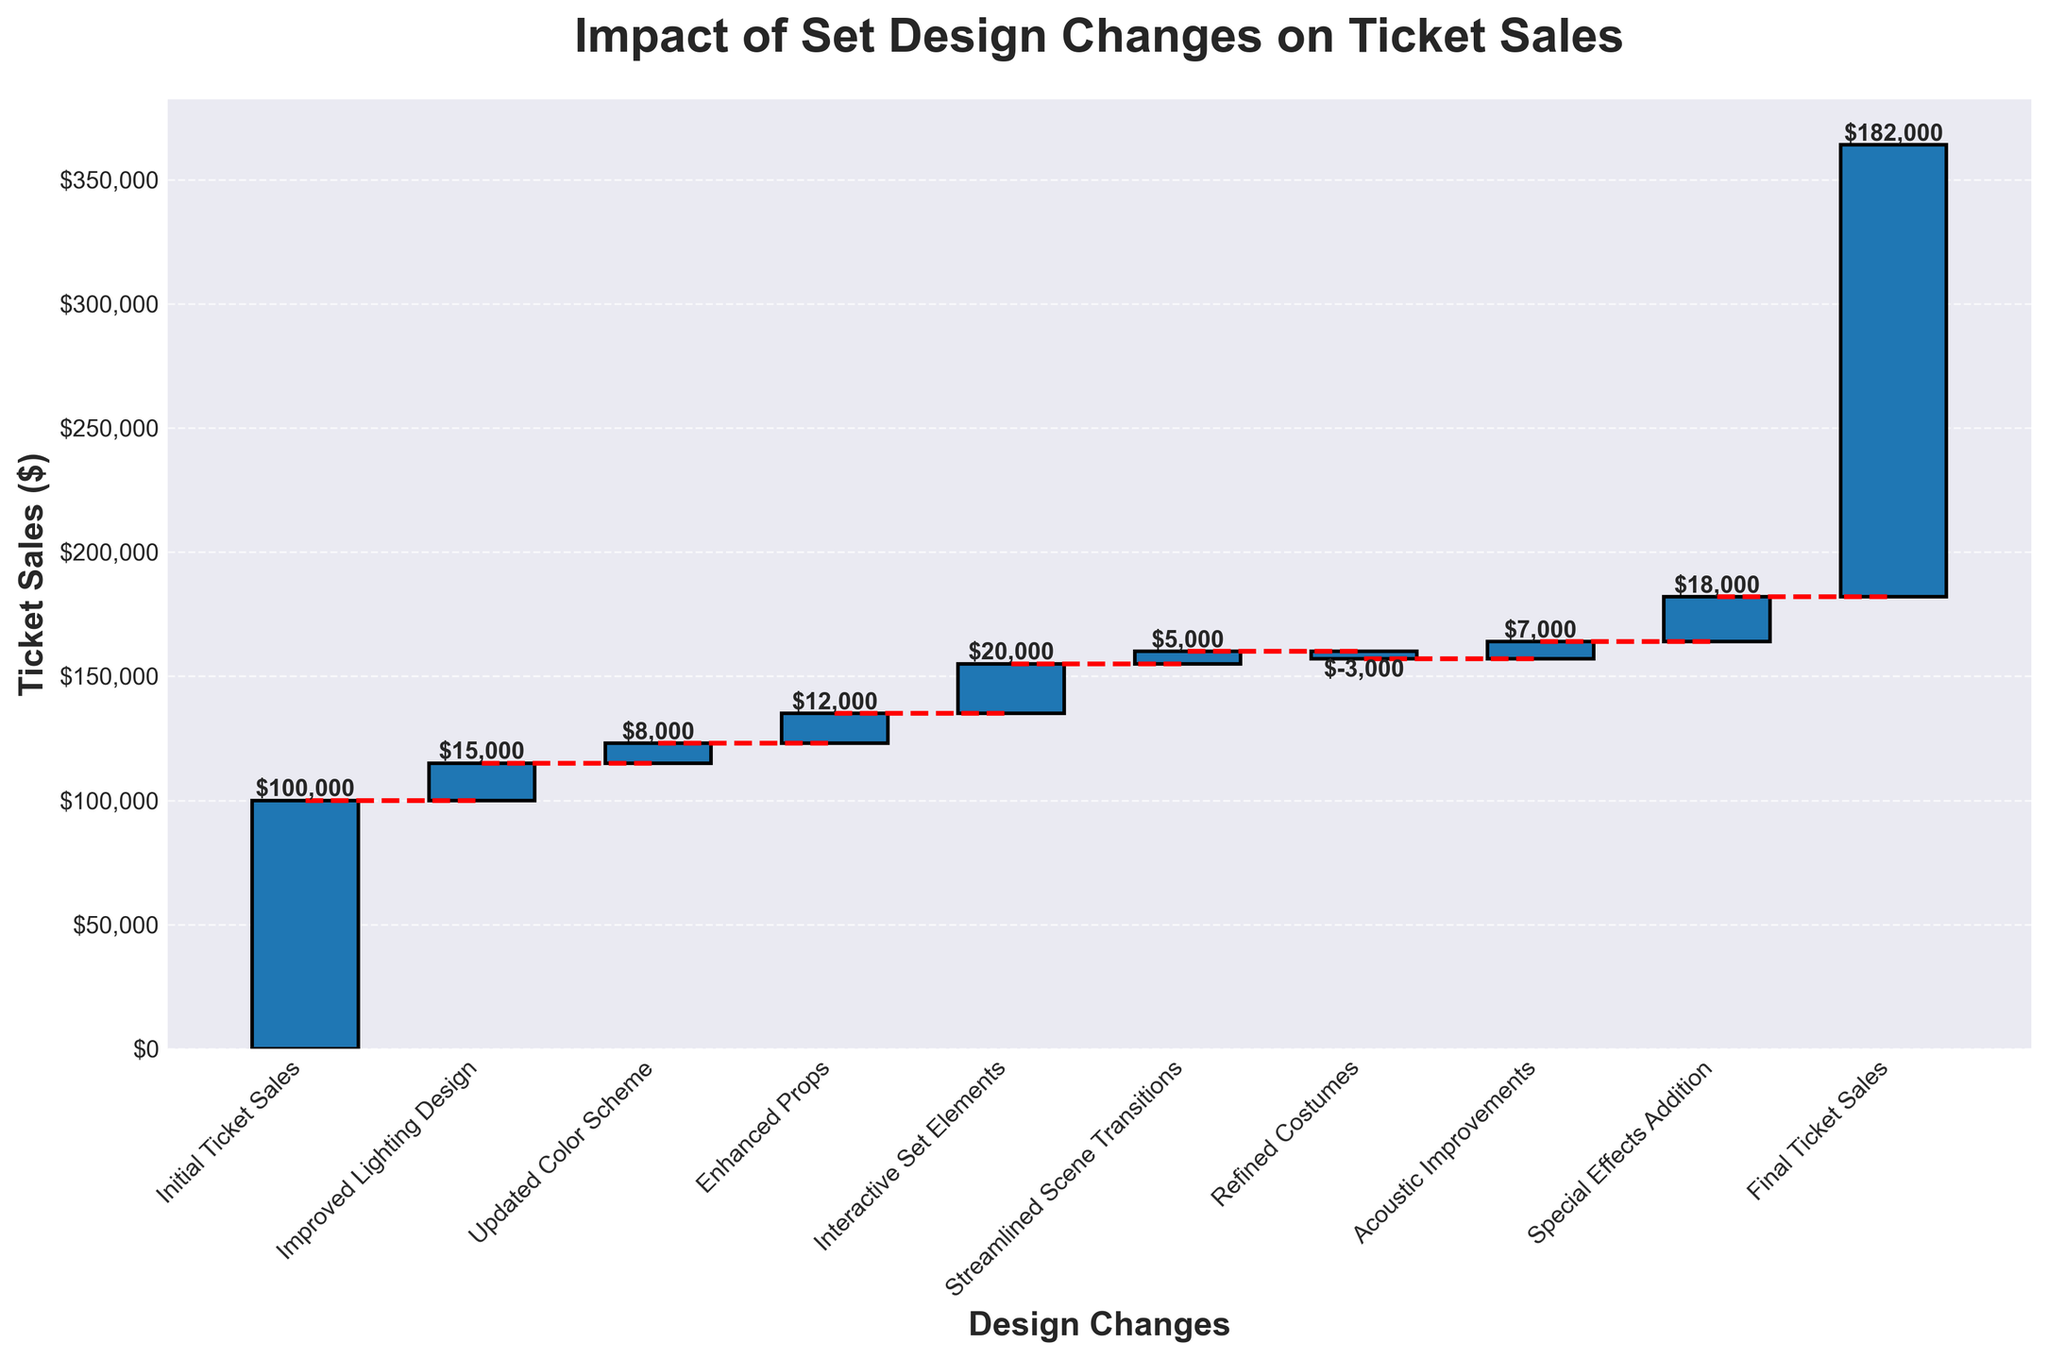What's the title of the chart? The title is displayed prominently at the top of the chart and provides a summary of what the chart is about.
Answer: Impact of Set Design Changes on Ticket Sales How many set design changes were tested in total? Count the total number of categories listed on the x-axis, excluding the initial and final values.
Answer: 7 What is the value change due to acoustic improvements? Look for the bar labeled “Acoustic Improvements” and read the value indicated.
Answer: $7,000 What is the cumulative ticket sales after the interactive set elements were added? The cumulative ticket sales can be found by looking at the position of the top edge of the bar labeled “Interactive Set Elements.” This value is the sum of initial ticket sales plus all additions and subtractions until that point.
Answer: $160,000 Which set design change had the most significant positive impact on ticket sales? Compare the height of the bars representing positive changes and identify the one with the maximum height.
Answer: Interactive Set Elements Which set design change caused a decrease in ticket sales? Look for a bar that extends downwards (negative value), which represents a decrease.
Answer: Refined Costumes By how much did the improved lighting design increase ticket sales? Look at the value label of the bar corresponding to “Improved Lighting Design.”
Answer: $15,000 What's the difference in ticket sales between the set design change with the greatest positive impact and the one with the greatest negative impact? Identify the values of the highest positive change (interactive set elements: $20,000) and the greatest negative change (refined costumes: -$3,000) and calculate the difference between them.
Answer: $23,000 How much did the ticket sales increase as a result of special effects addition? Read the value indicated on the bar labeled “Special Effects Addition.”
Answer: $18,000 Which design change generated the highest cumulative ticket sales before the final ticket sales tally? Sum the values incrementally and note when cumulative sales hit their peak just before the final entry. Compare these sums for each category.
Answer: Special Effects Addition 